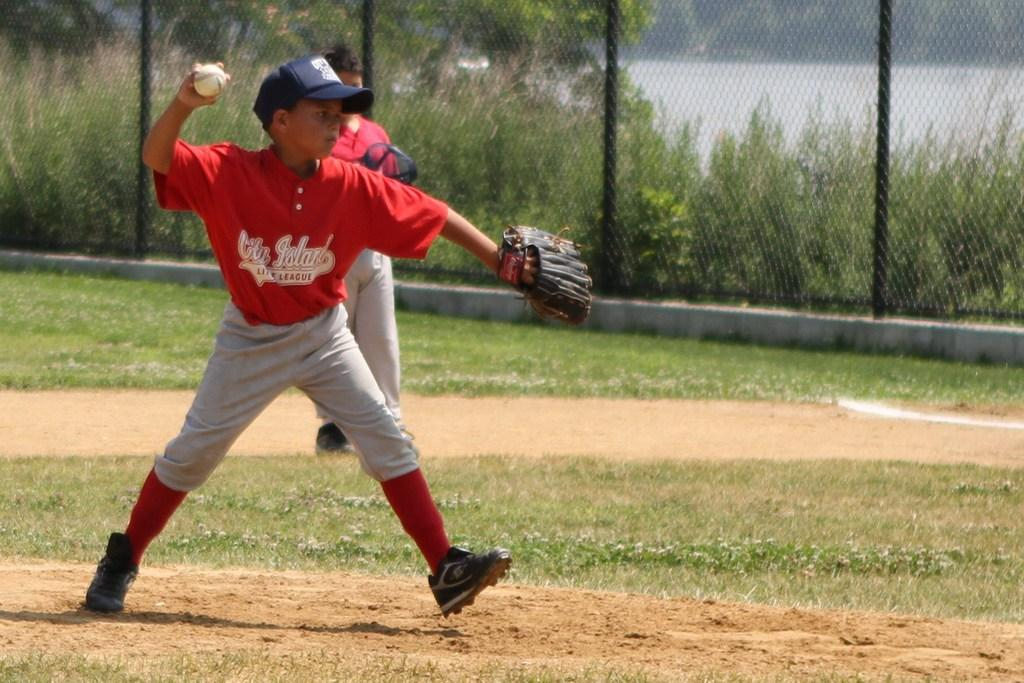<image>
Create a compact narrative representing the image presented. A boy playing for City Island Little League is pitching the ball. 